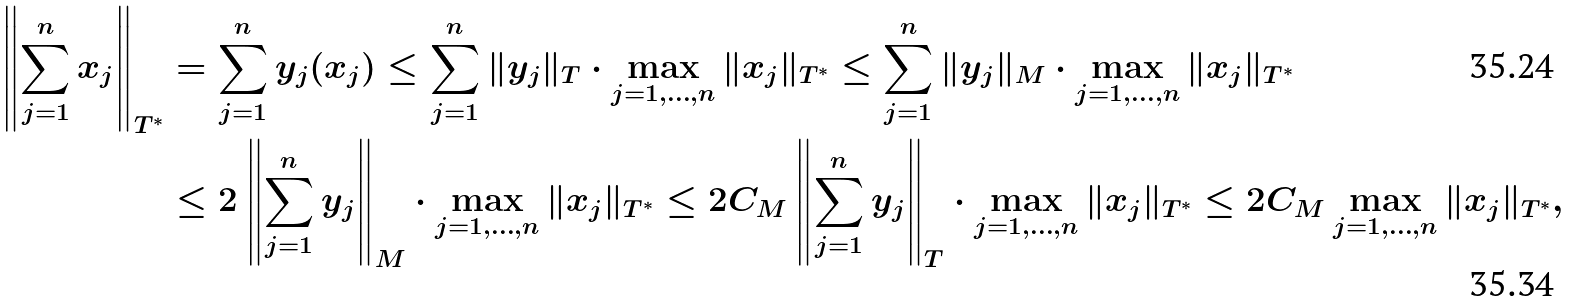<formula> <loc_0><loc_0><loc_500><loc_500>\left \| \sum _ { j = 1 } ^ { n } x _ { j } \right \| _ { T ^ { * } } & = \sum _ { j = 1 } ^ { n } y _ { j } ( x _ { j } ) \leq \sum _ { j = 1 } ^ { n } \| y _ { j } \| _ { T } \cdot \max _ { j = 1 , \dots , n } \| x _ { j } \| _ { T ^ { * } } \leq \sum _ { j = 1 } ^ { n } \| y _ { j } \| _ { M } \cdot \max _ { j = 1 , \dots , n } \| x _ { j } \| _ { T ^ { * } } \\ & \leq 2 \left \| \sum _ { j = 1 } ^ { n } y _ { j } \right \| _ { M } \cdot \max _ { j = 1 , \dots , n } \| x _ { j } \| _ { T ^ { * } } \leq 2 C _ { M } \left \| \sum _ { j = 1 } ^ { n } y _ { j } \right \| _ { T } \cdot \max _ { j = 1 , \dots , n } \| x _ { j } \| _ { T ^ { * } } \leq 2 C _ { M } \max _ { j = 1 , \dots , n } \| x _ { j } \| _ { T ^ { * } } ,</formula> 